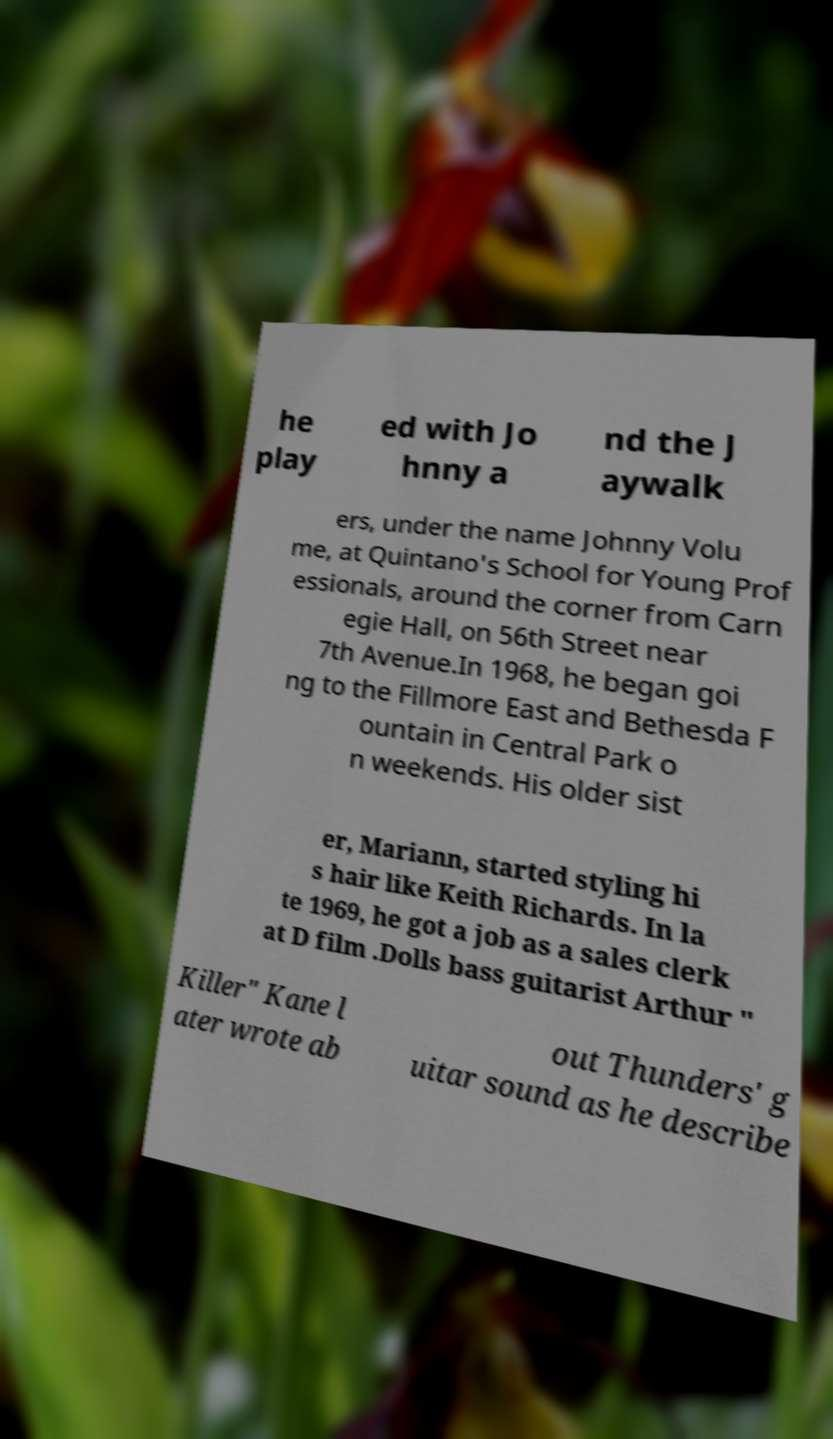Please identify and transcribe the text found in this image. he play ed with Jo hnny a nd the J aywalk ers, under the name Johnny Volu me, at Quintano's School for Young Prof essionals, around the corner from Carn egie Hall, on 56th Street near 7th Avenue.In 1968, he began goi ng to the Fillmore East and Bethesda F ountain in Central Park o n weekends. His older sist er, Mariann, started styling hi s hair like Keith Richards. In la te 1969, he got a job as a sales clerk at D film .Dolls bass guitarist Arthur " Killer" Kane l ater wrote ab out Thunders' g uitar sound as he describe 